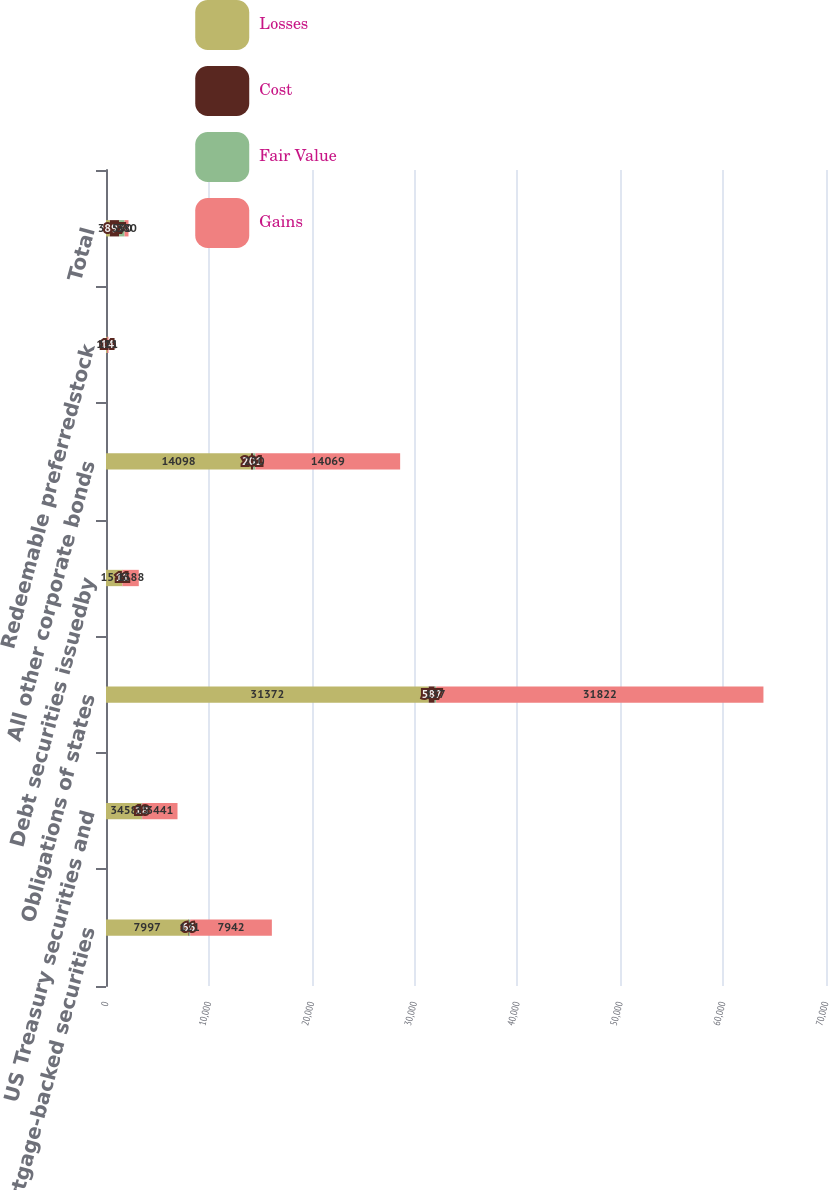Convert chart to OTSL. <chart><loc_0><loc_0><loc_500><loc_500><stacked_bar_chart><ecel><fcel>Mortgage-backed securities<fcel>US Treasury securities and<fcel>Obligations of states<fcel>Debt securities issuedby<fcel>All other corporate bonds<fcel>Redeemable preferredstock<fcel>Total<nl><fcel>Losses<fcel>7997<fcel>3458<fcel>31372<fcel>1583<fcel>14098<fcel>108<fcel>380<nl><fcel>Cost<fcel>66<fcel>18<fcel>587<fcel>11<fcel>201<fcel>14<fcel>897<nl><fcel>Fair Value<fcel>121<fcel>35<fcel>137<fcel>6<fcel>230<fcel>1<fcel>530<nl><fcel>Gains<fcel>7942<fcel>3441<fcel>31822<fcel>1588<fcel>14069<fcel>121<fcel>380<nl></chart> 